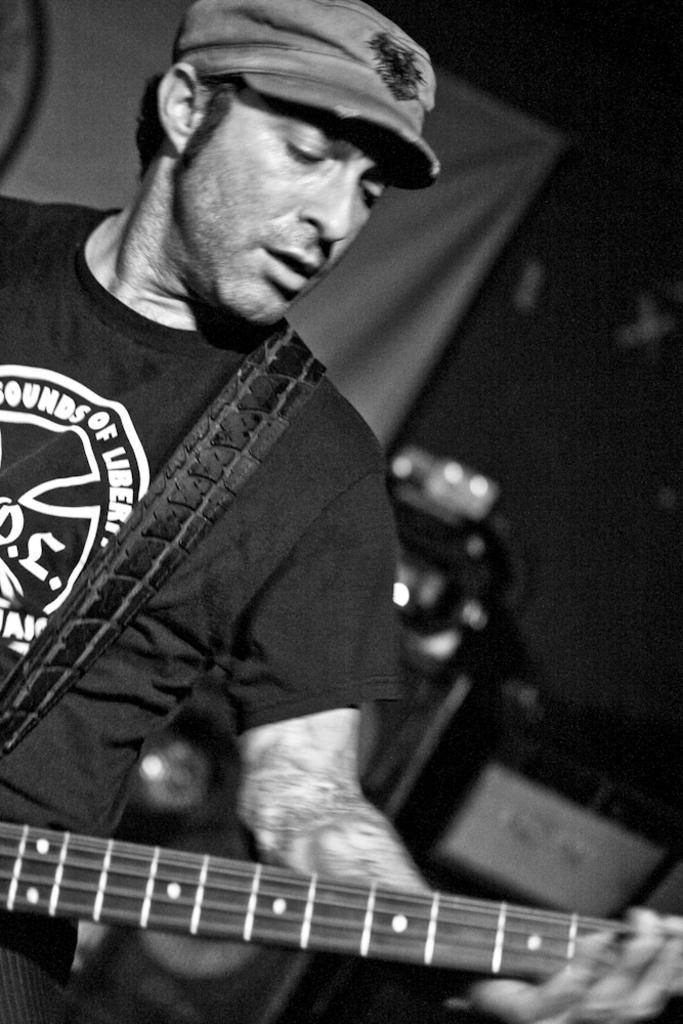What is the main subject of the image? There is a person in the image. What is the person wearing? The person is wearing a black t-shirt. What is the person holding in their hands? The person is holding a guitar in their hands. What type of quilt is being used as a grip on the guitar in the image? There is no quilt present in the image, and the person is not using a quilt as a grip on the guitar. 